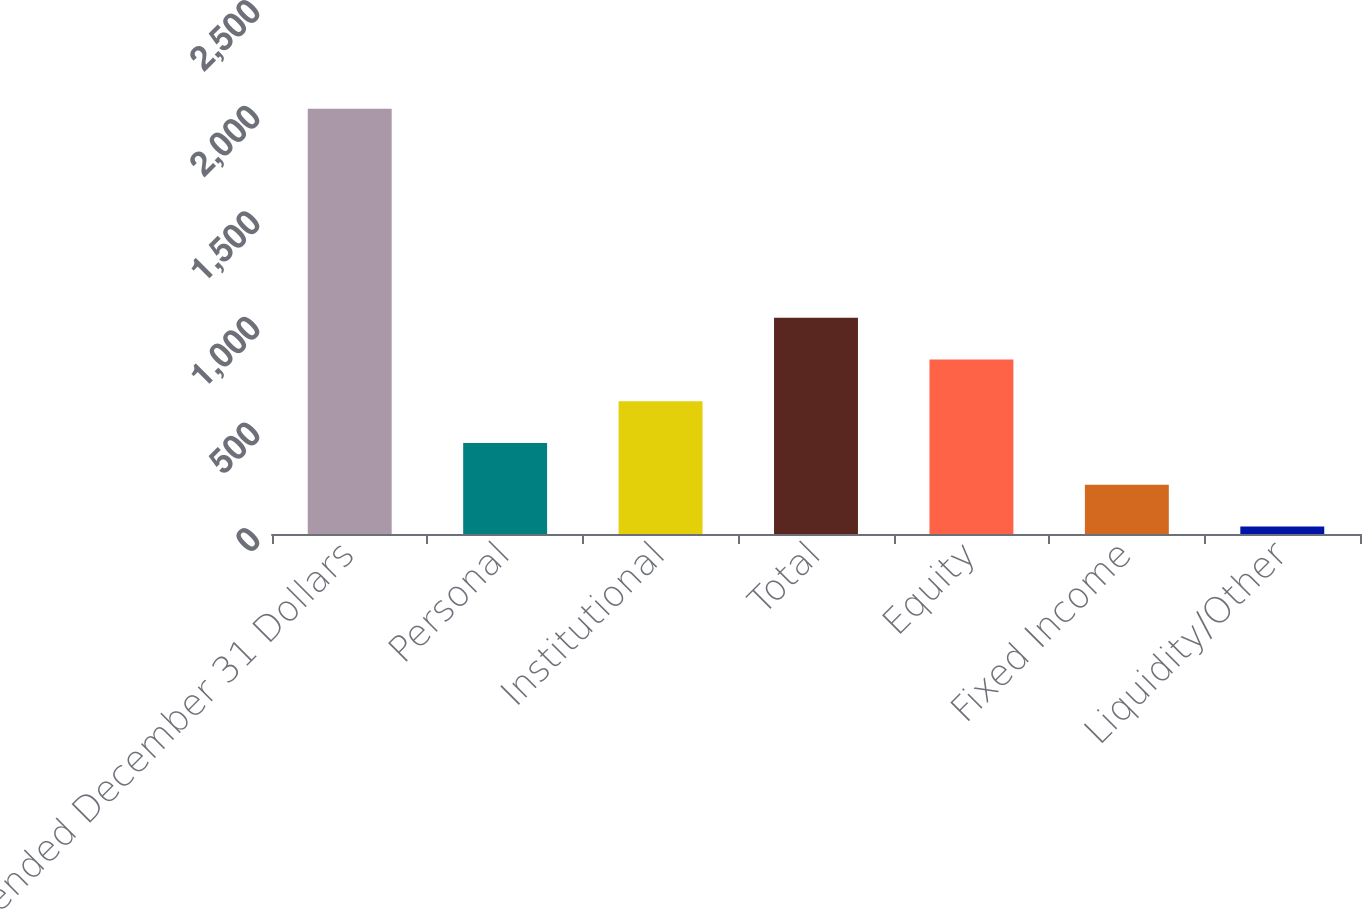<chart> <loc_0><loc_0><loc_500><loc_500><bar_chart><fcel>Year ended December 31 Dollars<fcel>Personal<fcel>Institutional<fcel>Total<fcel>Equity<fcel>Fixed Income<fcel>Liquidity/Other<nl><fcel>2013<fcel>430.6<fcel>628.4<fcel>1024<fcel>826.2<fcel>232.8<fcel>35<nl></chart> 